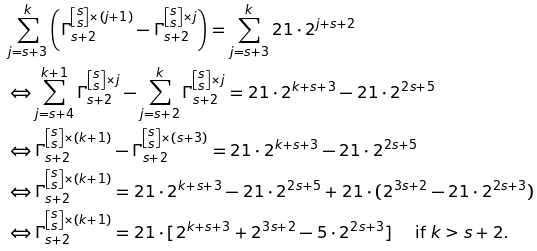<formula> <loc_0><loc_0><loc_500><loc_500>& \sum _ { j = s + 3 } ^ { k } \left ( \Gamma _ { s + 2 } ^ { \left [ \substack { s \\ s } \right ] \times ( j + 1 ) } - \Gamma _ { s + 2 } ^ { \left [ \substack { s \\ s } \right ] \times j } \right ) = \sum _ { j = s + 3 } ^ { k } 2 1 \cdot 2 ^ { j + s + 2 } \\ & \Leftrightarrow \sum _ { j = s + 4 } ^ { k + 1 } \Gamma _ { s + 2 } ^ { \left [ \substack { s \\ s } \right ] \times j } - \sum _ { j = s + 2 } ^ { k } \Gamma _ { s + 2 } ^ { \left [ \substack { s \\ s } \right ] \times j } = 2 1 \cdot 2 ^ { k + s + 3 } - 2 1 \cdot 2 ^ { 2 s + 5 } \\ & \Leftrightarrow \Gamma _ { s + 2 } ^ { \left [ \substack { s \\ s } \right ] \times ( k + 1 ) } - \Gamma _ { s + 2 } ^ { \left [ \substack { s \\ s } \right ] \times ( s + 3 ) } = 2 1 \cdot 2 ^ { k + s + 3 } - 2 1 \cdot 2 ^ { 2 s + 5 } \\ & \Leftrightarrow \Gamma _ { s + 2 } ^ { \left [ \substack { s \\ s } \right ] \times ( k + 1 ) } = 2 1 \cdot 2 ^ { k + s + 3 } - 2 1 \cdot 2 ^ { 2 s + 5 } + 2 1 \cdot ( 2 ^ { 3 s + 2 } - 2 1 \cdot 2 ^ { 2 s + 3 } ) \\ & \Leftrightarrow \Gamma _ { s + 2 } ^ { \left [ \substack { s \\ s } \right ] \times ( k + 1 ) } = 2 1 \cdot [ 2 ^ { k + s + 3 } + 2 ^ { 3 s + 2 } - 5 \cdot 2 ^ { 2 s + 3 } ] \quad \text { if $ k > s + 2 $} . \\ &</formula> 